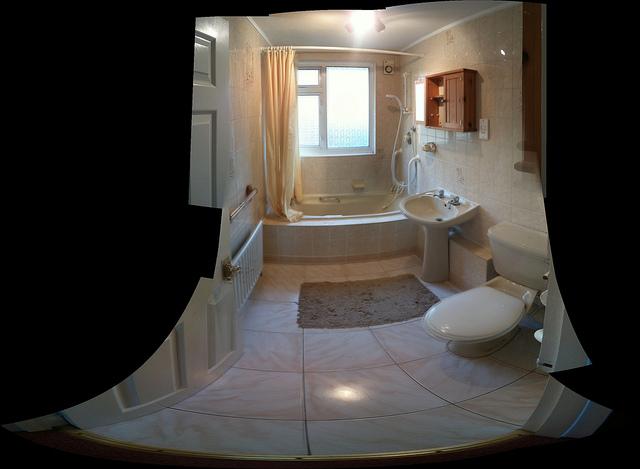Is there a place to shower here?
Quick response, please. Yes. Can you see what is outside the window?
Write a very short answer. No. Is the window open?
Answer briefly. No. Is there anyone in the room?
Keep it brief. No. 